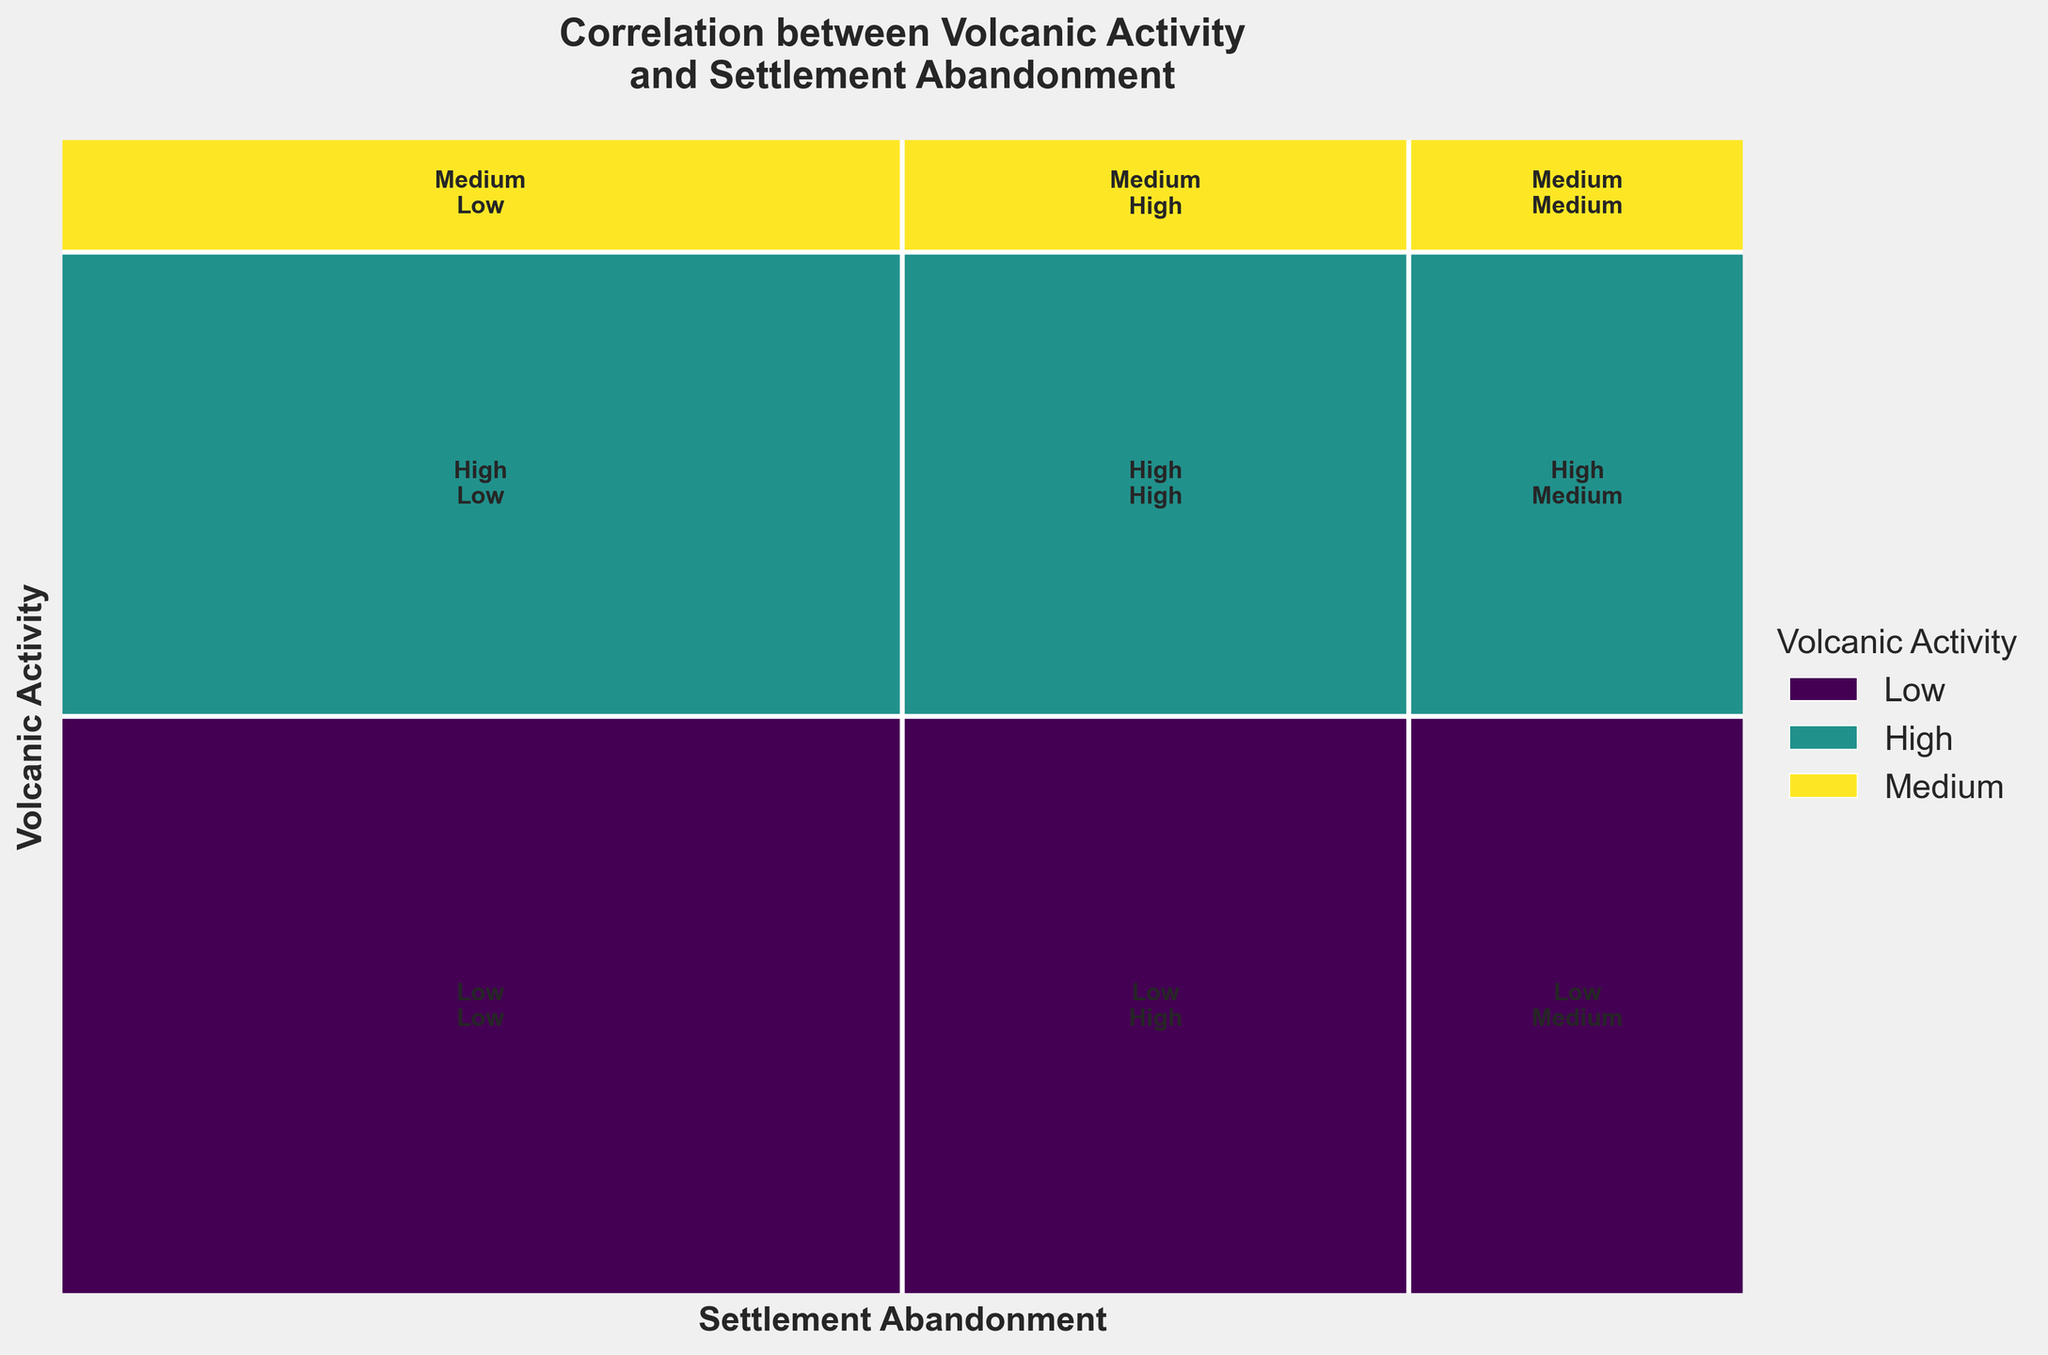What is the title of the figure? The title is typically placed at the top of the plot in bold to explain the main focus of the figure. Here, it reads "Correlation between Volcanic Activity and Settlement Abandonment."
Answer: Correlation between Volcanic Activity and Settlement Abandonment What are the axes labels in the figure? The x-axis is labeled "Settlement Abandonment," and the y-axis is labeled "Volcanic Activity." This indicates the dimensions being compared.
Answer: Settlement Abandonment, Volcanic Activity Which volcanic activity level covers the most height in the mosaic plot? By observing the vertical distribution, the volcanic activity level that covers the most height represents the highest proportional occurrence. In this case, "High" volcanic activity spans the greatest vertical section.
Answer: High How many and which regions are represented with their volcanic activity and settlement abandonment rates? The plot's legend and color-coded sections represent five regions: Vesuvius, Santorini, Popocatépetl, Mount Tambora, and Krakatoa. Counting these distinct sections confirms the total.
Answer: Five regions: Vesuvius, Santorini, Popocatépetl, Mount Tambora, Krakatoa Which settlement abandonment rate has the largest area for High volcanic activity? Finding the largest rectangle for High volcanic activity and checking the label within reveals that the largest area corresponds to "High" settlement abandonment rate.
Answer: High Between High and Medium volcanic activity, which rate of settlement abandonment has a more significant combined area? By comparing combined areas within the High and Medium vertical sections, High volcanic activity has larger combined areas for settlement abandonment rates "High" and "Medium" than Medium volcanic activity.
Answer: High For which volcanic activity level does Low settlement abandonment occur most frequently? To determine dominance in the plot, we see which regions have the largest areas vertically aligned with "Low" settlement abandonment; "Low" volcanic activity corresponds to this.
Answer: Low Which volcanic activity level has a constant settlement abandonment rate across all regions? Observing that rectangles' positions in relation to corresponding volcanic activity levels show "Low" volcanic activity maintains a consistent "Low" settlement abandonment rate across all regions.
Answer: Low Is there any volcanic activity level with no "Low" settlement abandonment rate? Only Medium volcanic activity lacks a rectangle intersecting with "Low" settlement abandonment rate, meaning it never coincides across regions.
Answer: Medium What is the most frequent pair of volcanic activity and settlement abandonment rates? The size of each combined rectangle conveys frequency. The "High" volcanic activity paired with "High" settlement abandonment rate rectangle has the largest combined area.
Answer: High High 